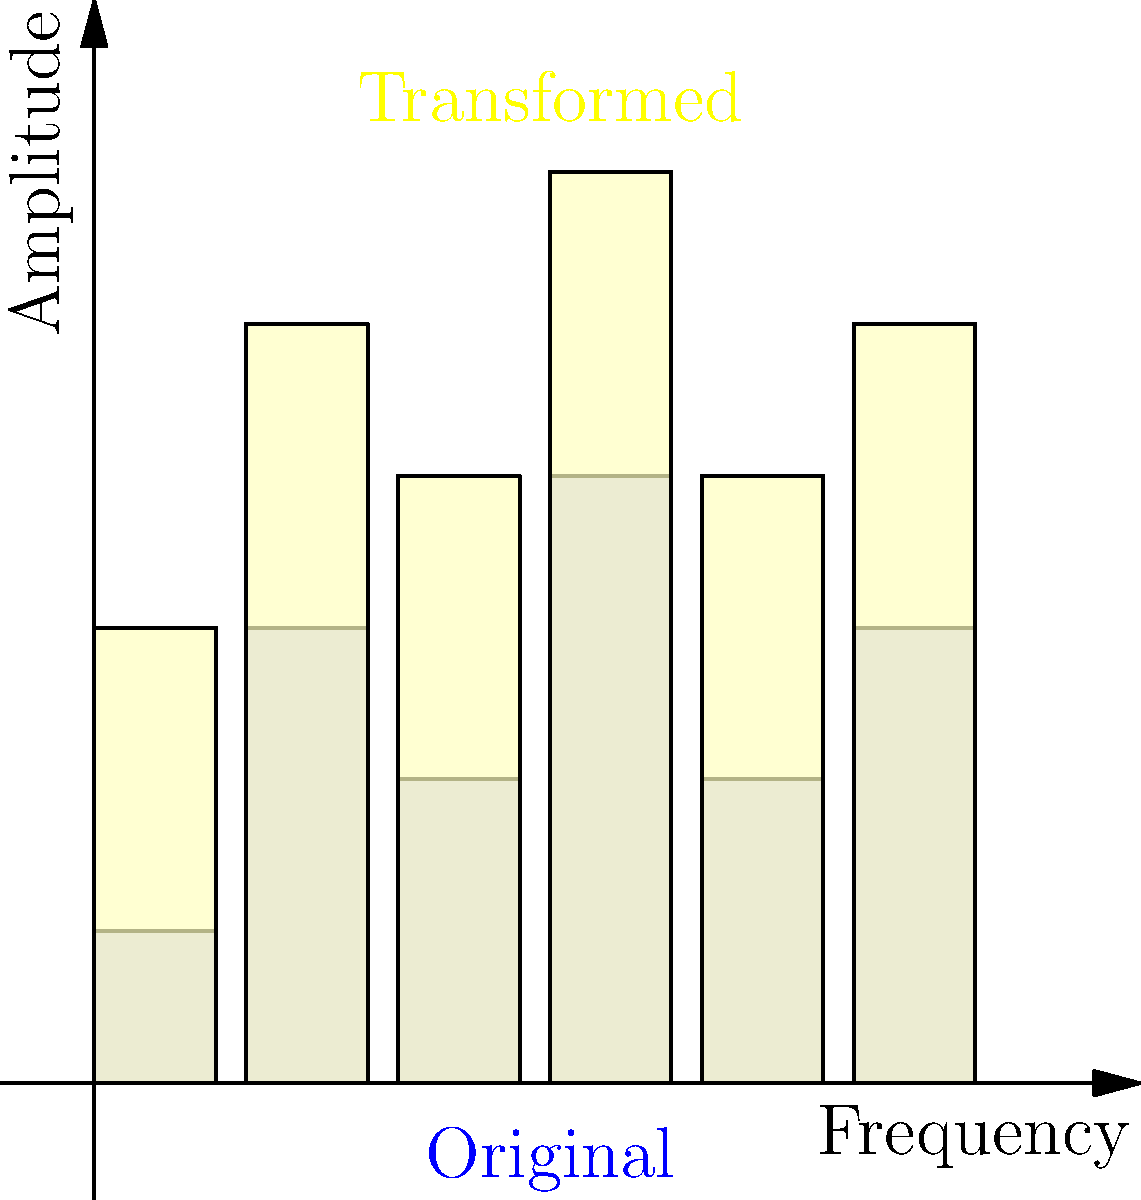As a '90s DJ, you're adjusting the equalizer on your mixer. The blue bars represent the original equalizer settings, and the yellow bars show the transformed settings. If the transformation is described by the function $f(x) = 2x + 1$, what is the amplitude of the transformed middle bar (third from left)? To solve this problem, we need to follow these steps:

1. Identify the original amplitude of the middle bar (third from left) in the blue set.
   The original amplitude is 2.

2. Apply the transformation function $f(x) = 2x + 1$ to this value:
   $f(2) = 2(2) + 1$

3. Simplify the equation:
   $f(2) = 4 + 1 = 5$

Therefore, the amplitude of the transformed middle bar is 5, which matches the yellow bar in the diagram.

This transformation represents a linear change to the equalizer settings, where each amplitude is doubled and then increased by 1. Such a transformation could be used to boost the overall volume and add a baseline increase across all frequencies, creating a more intense sound profile for a '90s dance track.
Answer: 5 